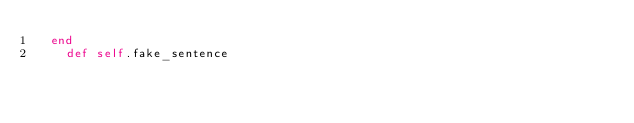Convert code to text. <code><loc_0><loc_0><loc_500><loc_500><_Ruby_>  end
    def self.fake_sentence</code> 